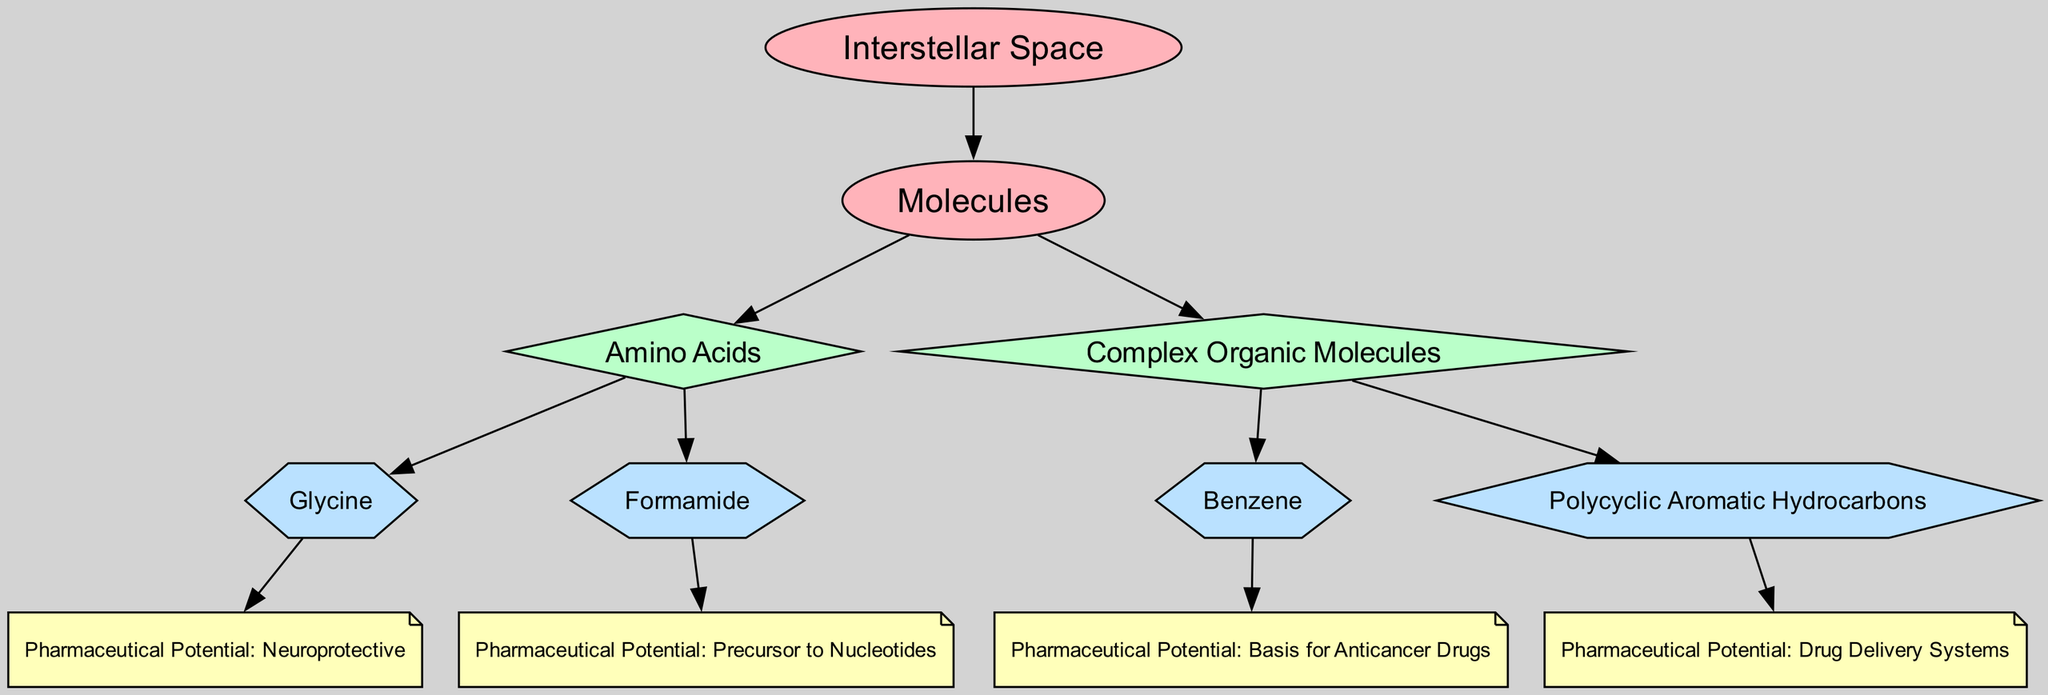What is the total number of molecules listed in the diagram? The diagram shows two categories of molecules: amino acids and complex organic molecules. Under amino acids, there are two molecules (Glycine and Formamide), and under complex organic molecules, there are two molecules (Benzene and Polycyclic Aromatic Hydrocarbons). Thus, the total number is 2 + 2 = 4.
Answer: 4 What is the pharmaceutical potential of Glycine? The diagram shows that Glycine has a property labeled as "Pharmaceutical Potential: Neuroprotective". This indicates that Glycine has potential pharmaceutical applications related to neuroprotection.
Answer: Neuroprotective Which molecule serves as a precursor to nucleotides? From the diagram, Formamide is specifically labeled with the property "Pharmaceutical Potential: Precursor to Nucleotides", indicating its potential role in nucleotide synthesis.
Answer: Formamide How many edges connect molecules to their pharmaceutical potential properties? Each molecule in the diagram is connected to exactly one pharmaceutical potential property. Since there are four molecules listed (Glycine, Formamide, Benzene, Polycyclic Aromatic Hydrocarbons), there are four edges connecting them to their corresponding properties, resulting in a total of 4 edges.
Answer: 4 Which type of molecules has the potential to serve as a basis for anticancer drugs? The diagram specifies that Benzene has the property labeled "Pharmaceutical Potential: Basis for Anticancer Drugs". Hence, Benzene is identified as such a molecule within the visual representation.
Answer: Benzene What is the relationship between amino acids and the complex organic molecules in the diagram? The diagram categorizes both amino acids and complex organic molecules as subcategories under the larger category of Molecules. They are distinct categories but part of the same overarching category, indicating that they belong to different classes of chemical entities.
Answer: Subcategories Which molecule is linked to drug delivery systems? The diagram explicitly indicates that Polycyclic Aromatic Hydrocarbons has the property "Pharmaceutical Potential: Drug Delivery Systems", assigning it potential relevance in drug delivery applications.
Answer: Polycyclic Aromatic Hydrocarbons What are the different types shown for the nodes within the diagram? The diagram features four node types: category, subcategory, molecule, and property. Each type is represented uniquely to convey various levels of information about the molecules and their applications in pharmaceuticals.
Answer: Four types What is the visual representation structure of the diagram? The diagram uses a hierarchical structure that starts with categories at the top and breaks down into subcategories and then into individual molecules, each of which connects to their respective pharmaceutical potential properties. This hierarchical arrangement illustrates the relationships clearly.
Answer: Hierarchical structure 